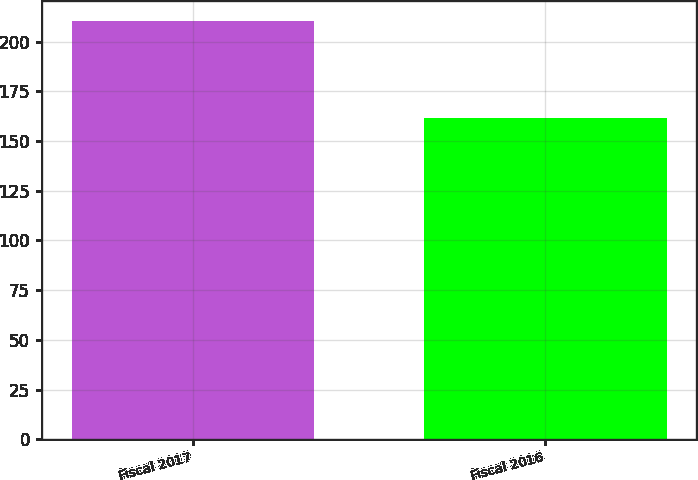Convert chart to OTSL. <chart><loc_0><loc_0><loc_500><loc_500><bar_chart><fcel>Fiscal 2017<fcel>Fiscal 2016<nl><fcel>210.1<fcel>161.8<nl></chart> 